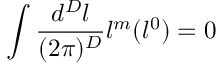<formula> <loc_0><loc_0><loc_500><loc_500>\int \frac { d ^ { D } l } { ( 2 \pi ) ^ { D } } l ^ { m } ( l ^ { 0 } ) = 0</formula> 